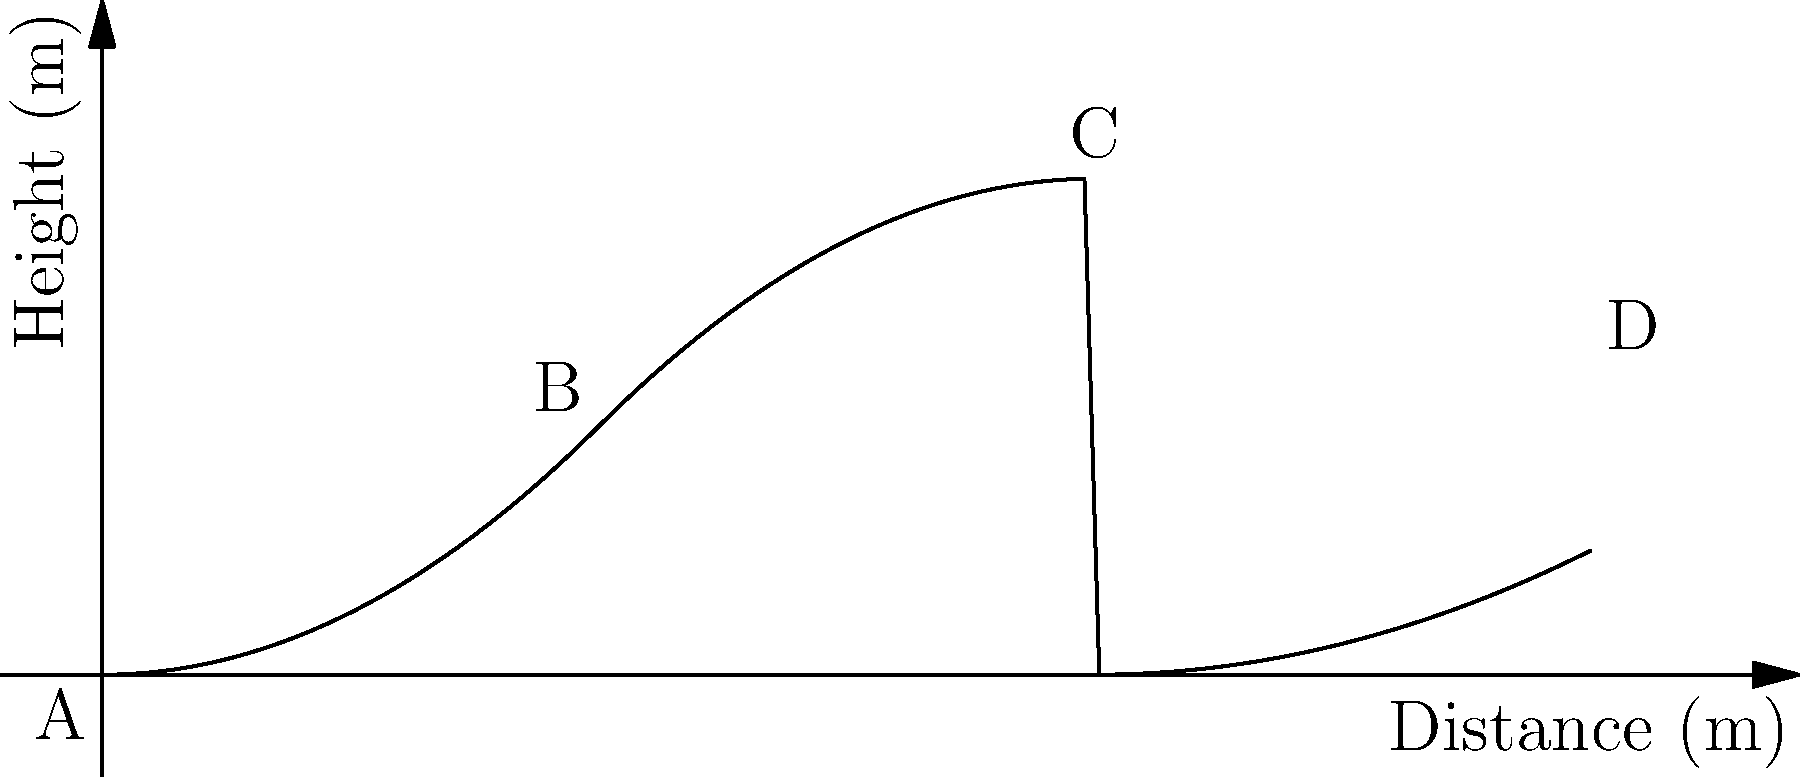As an experienced horse breeder and trainer, you've been asked to design a jumping course for an upcoming competition. The course needs to include a unique obstacle that follows a specific height profile. The profile is described by a piecewise polynomial function, as shown in the graph above. The x-axis represents the horizontal distance in meters, and the y-axis represents the height in meters. The function consists of three parts:

1. From A to B: $f(x) = 0.25x^2$
2. From B to C: $f(x) = -0.25(x-4)^2 + 2$
3. From C to D: $f(x) = 0.125(x-4)^2$

What is the maximum height of this obstacle, and at what horizontal distance does it occur? To find the maximum height of the obstacle and its corresponding horizontal distance, we need to analyze each piece of the function:

1. For the first piece (A to B), the function is increasing, so the maximum will be at B (x = 2).
   Height at B: $f(2) = 0.25(2)^2 = 1$ meter

2. For the second piece (B to C), we have an inverted parabola with its vertex at C (x = 4).
   Height at C: $f(4) = -0.25(4-4)^2 + 2 = 2$ meters

3. For the third piece (C to D), the function is increasing, so the maximum will be at C (x = 4).
   Height at C: $f(4) = 0.125(4-4)^2 = 0$ meters (which then increases to 1.25 meters at D)

Comparing these heights, we can see that the maximum occurs at point C, where x = 4 meters and the height is 2 meters.
Answer: Maximum height: 2 meters; Horizontal distance: 4 meters 